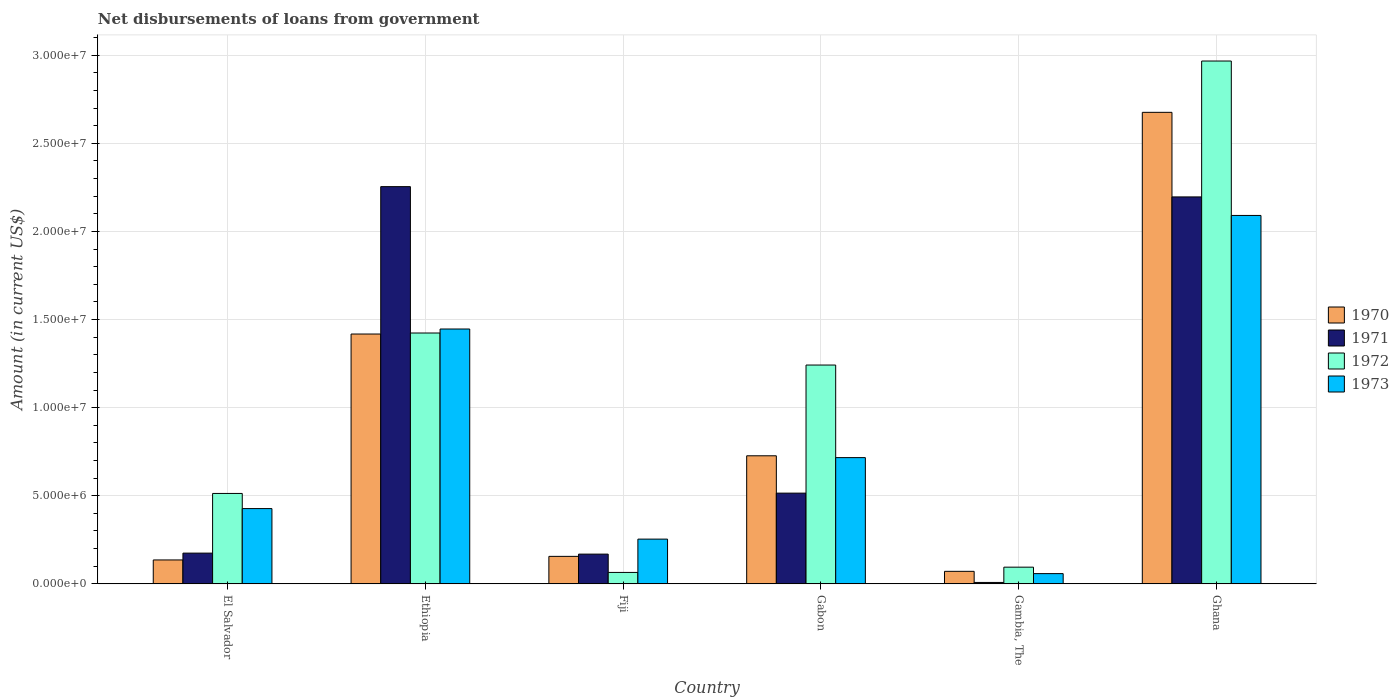How many different coloured bars are there?
Offer a terse response. 4. How many groups of bars are there?
Keep it short and to the point. 6. Are the number of bars per tick equal to the number of legend labels?
Ensure brevity in your answer.  Yes. Are the number of bars on each tick of the X-axis equal?
Make the answer very short. Yes. How many bars are there on the 2nd tick from the left?
Your response must be concise. 4. How many bars are there on the 6th tick from the right?
Offer a very short reply. 4. In how many cases, is the number of bars for a given country not equal to the number of legend labels?
Your response must be concise. 0. What is the amount of loan disbursed from government in 1972 in Gambia, The?
Make the answer very short. 9.48e+05. Across all countries, what is the maximum amount of loan disbursed from government in 1971?
Keep it short and to the point. 2.25e+07. Across all countries, what is the minimum amount of loan disbursed from government in 1973?
Ensure brevity in your answer.  5.81e+05. In which country was the amount of loan disbursed from government in 1973 maximum?
Keep it short and to the point. Ghana. In which country was the amount of loan disbursed from government in 1973 minimum?
Ensure brevity in your answer.  Gambia, The. What is the total amount of loan disbursed from government in 1972 in the graph?
Provide a succinct answer. 6.31e+07. What is the difference between the amount of loan disbursed from government in 1970 in Fiji and that in Gabon?
Offer a very short reply. -5.71e+06. What is the difference between the amount of loan disbursed from government in 1970 in Gambia, The and the amount of loan disbursed from government in 1973 in El Salvador?
Make the answer very short. -3.56e+06. What is the average amount of loan disbursed from government in 1973 per country?
Make the answer very short. 8.32e+06. What is the difference between the amount of loan disbursed from government of/in 1973 and amount of loan disbursed from government of/in 1970 in Ghana?
Your response must be concise. -5.85e+06. What is the ratio of the amount of loan disbursed from government in 1972 in Gambia, The to that in Ghana?
Make the answer very short. 0.03. What is the difference between the highest and the second highest amount of loan disbursed from government in 1970?
Give a very brief answer. 1.95e+07. What is the difference between the highest and the lowest amount of loan disbursed from government in 1970?
Ensure brevity in your answer.  2.60e+07. What does the 3rd bar from the left in Gabon represents?
Provide a succinct answer. 1972. What does the 3rd bar from the right in Fiji represents?
Provide a succinct answer. 1971. Is it the case that in every country, the sum of the amount of loan disbursed from government in 1972 and amount of loan disbursed from government in 1973 is greater than the amount of loan disbursed from government in 1971?
Keep it short and to the point. Yes. How many bars are there?
Offer a very short reply. 24. How many countries are there in the graph?
Your response must be concise. 6. What is the difference between two consecutive major ticks on the Y-axis?
Offer a very short reply. 5.00e+06. Are the values on the major ticks of Y-axis written in scientific E-notation?
Offer a terse response. Yes. Does the graph contain any zero values?
Your answer should be compact. No. Does the graph contain grids?
Your answer should be very brief. Yes. How are the legend labels stacked?
Keep it short and to the point. Vertical. What is the title of the graph?
Your answer should be very brief. Net disbursements of loans from government. Does "2003" appear as one of the legend labels in the graph?
Provide a succinct answer. No. What is the label or title of the Y-axis?
Offer a terse response. Amount (in current US$). What is the Amount (in current US$) in 1970 in El Salvador?
Provide a succinct answer. 1.36e+06. What is the Amount (in current US$) of 1971 in El Salvador?
Offer a terse response. 1.74e+06. What is the Amount (in current US$) of 1972 in El Salvador?
Offer a very short reply. 5.13e+06. What is the Amount (in current US$) in 1973 in El Salvador?
Your answer should be compact. 4.27e+06. What is the Amount (in current US$) in 1970 in Ethiopia?
Your answer should be compact. 1.42e+07. What is the Amount (in current US$) of 1971 in Ethiopia?
Provide a succinct answer. 2.25e+07. What is the Amount (in current US$) of 1972 in Ethiopia?
Make the answer very short. 1.42e+07. What is the Amount (in current US$) of 1973 in Ethiopia?
Give a very brief answer. 1.45e+07. What is the Amount (in current US$) of 1970 in Fiji?
Provide a succinct answer. 1.56e+06. What is the Amount (in current US$) in 1971 in Fiji?
Your answer should be compact. 1.69e+06. What is the Amount (in current US$) in 1972 in Fiji?
Offer a terse response. 6.49e+05. What is the Amount (in current US$) of 1973 in Fiji?
Make the answer very short. 2.54e+06. What is the Amount (in current US$) in 1970 in Gabon?
Provide a succinct answer. 7.27e+06. What is the Amount (in current US$) of 1971 in Gabon?
Provide a short and direct response. 5.15e+06. What is the Amount (in current US$) in 1972 in Gabon?
Offer a very short reply. 1.24e+07. What is the Amount (in current US$) of 1973 in Gabon?
Your answer should be very brief. 7.16e+06. What is the Amount (in current US$) in 1970 in Gambia, The?
Your answer should be compact. 7.11e+05. What is the Amount (in current US$) of 1972 in Gambia, The?
Keep it short and to the point. 9.48e+05. What is the Amount (in current US$) of 1973 in Gambia, The?
Your response must be concise. 5.81e+05. What is the Amount (in current US$) in 1970 in Ghana?
Ensure brevity in your answer.  2.68e+07. What is the Amount (in current US$) in 1971 in Ghana?
Your answer should be compact. 2.20e+07. What is the Amount (in current US$) of 1972 in Ghana?
Provide a short and direct response. 2.97e+07. What is the Amount (in current US$) in 1973 in Ghana?
Offer a terse response. 2.09e+07. Across all countries, what is the maximum Amount (in current US$) of 1970?
Offer a terse response. 2.68e+07. Across all countries, what is the maximum Amount (in current US$) of 1971?
Your answer should be very brief. 2.25e+07. Across all countries, what is the maximum Amount (in current US$) of 1972?
Make the answer very short. 2.97e+07. Across all countries, what is the maximum Amount (in current US$) of 1973?
Provide a succinct answer. 2.09e+07. Across all countries, what is the minimum Amount (in current US$) in 1970?
Keep it short and to the point. 7.11e+05. Across all countries, what is the minimum Amount (in current US$) of 1971?
Offer a terse response. 8.00e+04. Across all countries, what is the minimum Amount (in current US$) of 1972?
Your response must be concise. 6.49e+05. Across all countries, what is the minimum Amount (in current US$) of 1973?
Provide a succinct answer. 5.81e+05. What is the total Amount (in current US$) of 1970 in the graph?
Provide a short and direct response. 5.18e+07. What is the total Amount (in current US$) of 1971 in the graph?
Provide a succinct answer. 5.32e+07. What is the total Amount (in current US$) of 1972 in the graph?
Offer a very short reply. 6.31e+07. What is the total Amount (in current US$) of 1973 in the graph?
Provide a succinct answer. 4.99e+07. What is the difference between the Amount (in current US$) in 1970 in El Salvador and that in Ethiopia?
Your answer should be very brief. -1.28e+07. What is the difference between the Amount (in current US$) in 1971 in El Salvador and that in Ethiopia?
Offer a very short reply. -2.08e+07. What is the difference between the Amount (in current US$) of 1972 in El Salvador and that in Ethiopia?
Your answer should be very brief. -9.10e+06. What is the difference between the Amount (in current US$) of 1973 in El Salvador and that in Ethiopia?
Your response must be concise. -1.02e+07. What is the difference between the Amount (in current US$) of 1970 in El Salvador and that in Fiji?
Offer a very short reply. -2.03e+05. What is the difference between the Amount (in current US$) of 1971 in El Salvador and that in Fiji?
Ensure brevity in your answer.  5.70e+04. What is the difference between the Amount (in current US$) in 1972 in El Salvador and that in Fiji?
Keep it short and to the point. 4.48e+06. What is the difference between the Amount (in current US$) in 1973 in El Salvador and that in Fiji?
Keep it short and to the point. 1.73e+06. What is the difference between the Amount (in current US$) of 1970 in El Salvador and that in Gabon?
Offer a very short reply. -5.91e+06. What is the difference between the Amount (in current US$) of 1971 in El Salvador and that in Gabon?
Offer a terse response. -3.40e+06. What is the difference between the Amount (in current US$) in 1972 in El Salvador and that in Gabon?
Offer a terse response. -7.29e+06. What is the difference between the Amount (in current US$) in 1973 in El Salvador and that in Gabon?
Make the answer very short. -2.89e+06. What is the difference between the Amount (in current US$) in 1970 in El Salvador and that in Gambia, The?
Provide a succinct answer. 6.46e+05. What is the difference between the Amount (in current US$) in 1971 in El Salvador and that in Gambia, The?
Your answer should be compact. 1.66e+06. What is the difference between the Amount (in current US$) in 1972 in El Salvador and that in Gambia, The?
Ensure brevity in your answer.  4.18e+06. What is the difference between the Amount (in current US$) in 1973 in El Salvador and that in Gambia, The?
Your answer should be compact. 3.69e+06. What is the difference between the Amount (in current US$) in 1970 in El Salvador and that in Ghana?
Your answer should be very brief. -2.54e+07. What is the difference between the Amount (in current US$) in 1971 in El Salvador and that in Ghana?
Ensure brevity in your answer.  -2.02e+07. What is the difference between the Amount (in current US$) in 1972 in El Salvador and that in Ghana?
Give a very brief answer. -2.45e+07. What is the difference between the Amount (in current US$) of 1973 in El Salvador and that in Ghana?
Make the answer very short. -1.66e+07. What is the difference between the Amount (in current US$) in 1970 in Ethiopia and that in Fiji?
Provide a short and direct response. 1.26e+07. What is the difference between the Amount (in current US$) of 1971 in Ethiopia and that in Fiji?
Offer a very short reply. 2.09e+07. What is the difference between the Amount (in current US$) in 1972 in Ethiopia and that in Fiji?
Your response must be concise. 1.36e+07. What is the difference between the Amount (in current US$) of 1973 in Ethiopia and that in Fiji?
Ensure brevity in your answer.  1.19e+07. What is the difference between the Amount (in current US$) in 1970 in Ethiopia and that in Gabon?
Your answer should be very brief. 6.91e+06. What is the difference between the Amount (in current US$) in 1971 in Ethiopia and that in Gabon?
Keep it short and to the point. 1.74e+07. What is the difference between the Amount (in current US$) in 1972 in Ethiopia and that in Gabon?
Make the answer very short. 1.82e+06. What is the difference between the Amount (in current US$) of 1973 in Ethiopia and that in Gabon?
Make the answer very short. 7.30e+06. What is the difference between the Amount (in current US$) in 1970 in Ethiopia and that in Gambia, The?
Provide a short and direct response. 1.35e+07. What is the difference between the Amount (in current US$) in 1971 in Ethiopia and that in Gambia, The?
Provide a short and direct response. 2.25e+07. What is the difference between the Amount (in current US$) of 1972 in Ethiopia and that in Gambia, The?
Make the answer very short. 1.33e+07. What is the difference between the Amount (in current US$) in 1973 in Ethiopia and that in Gambia, The?
Give a very brief answer. 1.39e+07. What is the difference between the Amount (in current US$) in 1970 in Ethiopia and that in Ghana?
Offer a very short reply. -1.26e+07. What is the difference between the Amount (in current US$) in 1971 in Ethiopia and that in Ghana?
Ensure brevity in your answer.  5.83e+05. What is the difference between the Amount (in current US$) in 1972 in Ethiopia and that in Ghana?
Your answer should be very brief. -1.54e+07. What is the difference between the Amount (in current US$) in 1973 in Ethiopia and that in Ghana?
Offer a terse response. -6.44e+06. What is the difference between the Amount (in current US$) of 1970 in Fiji and that in Gabon?
Provide a short and direct response. -5.71e+06. What is the difference between the Amount (in current US$) in 1971 in Fiji and that in Gabon?
Your answer should be compact. -3.46e+06. What is the difference between the Amount (in current US$) of 1972 in Fiji and that in Gabon?
Ensure brevity in your answer.  -1.18e+07. What is the difference between the Amount (in current US$) in 1973 in Fiji and that in Gabon?
Make the answer very short. -4.62e+06. What is the difference between the Amount (in current US$) of 1970 in Fiji and that in Gambia, The?
Ensure brevity in your answer.  8.49e+05. What is the difference between the Amount (in current US$) of 1971 in Fiji and that in Gambia, The?
Offer a very short reply. 1.61e+06. What is the difference between the Amount (in current US$) in 1972 in Fiji and that in Gambia, The?
Provide a succinct answer. -2.99e+05. What is the difference between the Amount (in current US$) of 1973 in Fiji and that in Gambia, The?
Offer a very short reply. 1.96e+06. What is the difference between the Amount (in current US$) in 1970 in Fiji and that in Ghana?
Give a very brief answer. -2.52e+07. What is the difference between the Amount (in current US$) in 1971 in Fiji and that in Ghana?
Make the answer very short. -2.03e+07. What is the difference between the Amount (in current US$) of 1972 in Fiji and that in Ghana?
Offer a very short reply. -2.90e+07. What is the difference between the Amount (in current US$) in 1973 in Fiji and that in Ghana?
Your response must be concise. -1.84e+07. What is the difference between the Amount (in current US$) in 1970 in Gabon and that in Gambia, The?
Your response must be concise. 6.56e+06. What is the difference between the Amount (in current US$) of 1971 in Gabon and that in Gambia, The?
Provide a short and direct response. 5.07e+06. What is the difference between the Amount (in current US$) in 1972 in Gabon and that in Gambia, The?
Offer a very short reply. 1.15e+07. What is the difference between the Amount (in current US$) of 1973 in Gabon and that in Gambia, The?
Your response must be concise. 6.58e+06. What is the difference between the Amount (in current US$) in 1970 in Gabon and that in Ghana?
Offer a very short reply. -1.95e+07. What is the difference between the Amount (in current US$) of 1971 in Gabon and that in Ghana?
Give a very brief answer. -1.68e+07. What is the difference between the Amount (in current US$) in 1972 in Gabon and that in Ghana?
Keep it short and to the point. -1.73e+07. What is the difference between the Amount (in current US$) of 1973 in Gabon and that in Ghana?
Keep it short and to the point. -1.37e+07. What is the difference between the Amount (in current US$) of 1970 in Gambia, The and that in Ghana?
Keep it short and to the point. -2.60e+07. What is the difference between the Amount (in current US$) in 1971 in Gambia, The and that in Ghana?
Your answer should be compact. -2.19e+07. What is the difference between the Amount (in current US$) of 1972 in Gambia, The and that in Ghana?
Ensure brevity in your answer.  -2.87e+07. What is the difference between the Amount (in current US$) of 1973 in Gambia, The and that in Ghana?
Provide a short and direct response. -2.03e+07. What is the difference between the Amount (in current US$) in 1970 in El Salvador and the Amount (in current US$) in 1971 in Ethiopia?
Make the answer very short. -2.12e+07. What is the difference between the Amount (in current US$) in 1970 in El Salvador and the Amount (in current US$) in 1972 in Ethiopia?
Provide a short and direct response. -1.29e+07. What is the difference between the Amount (in current US$) in 1970 in El Salvador and the Amount (in current US$) in 1973 in Ethiopia?
Offer a very short reply. -1.31e+07. What is the difference between the Amount (in current US$) in 1971 in El Salvador and the Amount (in current US$) in 1972 in Ethiopia?
Offer a terse response. -1.25e+07. What is the difference between the Amount (in current US$) of 1971 in El Salvador and the Amount (in current US$) of 1973 in Ethiopia?
Provide a short and direct response. -1.27e+07. What is the difference between the Amount (in current US$) in 1972 in El Salvador and the Amount (in current US$) in 1973 in Ethiopia?
Give a very brief answer. -9.33e+06. What is the difference between the Amount (in current US$) of 1970 in El Salvador and the Amount (in current US$) of 1971 in Fiji?
Provide a succinct answer. -3.31e+05. What is the difference between the Amount (in current US$) in 1970 in El Salvador and the Amount (in current US$) in 1972 in Fiji?
Give a very brief answer. 7.08e+05. What is the difference between the Amount (in current US$) in 1970 in El Salvador and the Amount (in current US$) in 1973 in Fiji?
Provide a succinct answer. -1.18e+06. What is the difference between the Amount (in current US$) in 1971 in El Salvador and the Amount (in current US$) in 1972 in Fiji?
Give a very brief answer. 1.10e+06. What is the difference between the Amount (in current US$) in 1971 in El Salvador and the Amount (in current US$) in 1973 in Fiji?
Your answer should be compact. -7.94e+05. What is the difference between the Amount (in current US$) in 1972 in El Salvador and the Amount (in current US$) in 1973 in Fiji?
Give a very brief answer. 2.59e+06. What is the difference between the Amount (in current US$) of 1970 in El Salvador and the Amount (in current US$) of 1971 in Gabon?
Provide a short and direct response. -3.79e+06. What is the difference between the Amount (in current US$) of 1970 in El Salvador and the Amount (in current US$) of 1972 in Gabon?
Offer a very short reply. -1.11e+07. What is the difference between the Amount (in current US$) in 1970 in El Salvador and the Amount (in current US$) in 1973 in Gabon?
Make the answer very short. -5.81e+06. What is the difference between the Amount (in current US$) in 1971 in El Salvador and the Amount (in current US$) in 1972 in Gabon?
Your answer should be compact. -1.07e+07. What is the difference between the Amount (in current US$) of 1971 in El Salvador and the Amount (in current US$) of 1973 in Gabon?
Your answer should be compact. -5.42e+06. What is the difference between the Amount (in current US$) in 1972 in El Salvador and the Amount (in current US$) in 1973 in Gabon?
Make the answer very short. -2.03e+06. What is the difference between the Amount (in current US$) in 1970 in El Salvador and the Amount (in current US$) in 1971 in Gambia, The?
Offer a very short reply. 1.28e+06. What is the difference between the Amount (in current US$) of 1970 in El Salvador and the Amount (in current US$) of 1972 in Gambia, The?
Keep it short and to the point. 4.09e+05. What is the difference between the Amount (in current US$) of 1970 in El Salvador and the Amount (in current US$) of 1973 in Gambia, The?
Offer a very short reply. 7.76e+05. What is the difference between the Amount (in current US$) of 1971 in El Salvador and the Amount (in current US$) of 1972 in Gambia, The?
Your answer should be very brief. 7.97e+05. What is the difference between the Amount (in current US$) of 1971 in El Salvador and the Amount (in current US$) of 1973 in Gambia, The?
Offer a terse response. 1.16e+06. What is the difference between the Amount (in current US$) of 1972 in El Salvador and the Amount (in current US$) of 1973 in Gambia, The?
Your answer should be very brief. 4.55e+06. What is the difference between the Amount (in current US$) of 1970 in El Salvador and the Amount (in current US$) of 1971 in Ghana?
Ensure brevity in your answer.  -2.06e+07. What is the difference between the Amount (in current US$) of 1970 in El Salvador and the Amount (in current US$) of 1972 in Ghana?
Ensure brevity in your answer.  -2.83e+07. What is the difference between the Amount (in current US$) in 1970 in El Salvador and the Amount (in current US$) in 1973 in Ghana?
Offer a very short reply. -1.96e+07. What is the difference between the Amount (in current US$) in 1971 in El Salvador and the Amount (in current US$) in 1972 in Ghana?
Offer a terse response. -2.79e+07. What is the difference between the Amount (in current US$) of 1971 in El Salvador and the Amount (in current US$) of 1973 in Ghana?
Your answer should be very brief. -1.92e+07. What is the difference between the Amount (in current US$) of 1972 in El Salvador and the Amount (in current US$) of 1973 in Ghana?
Give a very brief answer. -1.58e+07. What is the difference between the Amount (in current US$) of 1970 in Ethiopia and the Amount (in current US$) of 1971 in Fiji?
Provide a short and direct response. 1.25e+07. What is the difference between the Amount (in current US$) of 1970 in Ethiopia and the Amount (in current US$) of 1972 in Fiji?
Offer a very short reply. 1.35e+07. What is the difference between the Amount (in current US$) in 1970 in Ethiopia and the Amount (in current US$) in 1973 in Fiji?
Give a very brief answer. 1.16e+07. What is the difference between the Amount (in current US$) in 1971 in Ethiopia and the Amount (in current US$) in 1972 in Fiji?
Your response must be concise. 2.19e+07. What is the difference between the Amount (in current US$) in 1971 in Ethiopia and the Amount (in current US$) in 1973 in Fiji?
Offer a very short reply. 2.00e+07. What is the difference between the Amount (in current US$) in 1972 in Ethiopia and the Amount (in current US$) in 1973 in Fiji?
Your response must be concise. 1.17e+07. What is the difference between the Amount (in current US$) in 1970 in Ethiopia and the Amount (in current US$) in 1971 in Gabon?
Offer a very short reply. 9.03e+06. What is the difference between the Amount (in current US$) in 1970 in Ethiopia and the Amount (in current US$) in 1972 in Gabon?
Your response must be concise. 1.76e+06. What is the difference between the Amount (in current US$) of 1970 in Ethiopia and the Amount (in current US$) of 1973 in Gabon?
Offer a very short reply. 7.01e+06. What is the difference between the Amount (in current US$) of 1971 in Ethiopia and the Amount (in current US$) of 1972 in Gabon?
Give a very brief answer. 1.01e+07. What is the difference between the Amount (in current US$) of 1971 in Ethiopia and the Amount (in current US$) of 1973 in Gabon?
Make the answer very short. 1.54e+07. What is the difference between the Amount (in current US$) in 1972 in Ethiopia and the Amount (in current US$) in 1973 in Gabon?
Offer a very short reply. 7.07e+06. What is the difference between the Amount (in current US$) in 1970 in Ethiopia and the Amount (in current US$) in 1971 in Gambia, The?
Your answer should be compact. 1.41e+07. What is the difference between the Amount (in current US$) in 1970 in Ethiopia and the Amount (in current US$) in 1972 in Gambia, The?
Offer a very short reply. 1.32e+07. What is the difference between the Amount (in current US$) of 1970 in Ethiopia and the Amount (in current US$) of 1973 in Gambia, The?
Your answer should be very brief. 1.36e+07. What is the difference between the Amount (in current US$) in 1971 in Ethiopia and the Amount (in current US$) in 1972 in Gambia, The?
Provide a succinct answer. 2.16e+07. What is the difference between the Amount (in current US$) in 1971 in Ethiopia and the Amount (in current US$) in 1973 in Gambia, The?
Your answer should be compact. 2.20e+07. What is the difference between the Amount (in current US$) of 1972 in Ethiopia and the Amount (in current US$) of 1973 in Gambia, The?
Your response must be concise. 1.37e+07. What is the difference between the Amount (in current US$) of 1970 in Ethiopia and the Amount (in current US$) of 1971 in Ghana?
Your answer should be very brief. -7.78e+06. What is the difference between the Amount (in current US$) of 1970 in Ethiopia and the Amount (in current US$) of 1972 in Ghana?
Your answer should be very brief. -1.55e+07. What is the difference between the Amount (in current US$) of 1970 in Ethiopia and the Amount (in current US$) of 1973 in Ghana?
Offer a terse response. -6.73e+06. What is the difference between the Amount (in current US$) of 1971 in Ethiopia and the Amount (in current US$) of 1972 in Ghana?
Your response must be concise. -7.13e+06. What is the difference between the Amount (in current US$) in 1971 in Ethiopia and the Amount (in current US$) in 1973 in Ghana?
Your answer should be very brief. 1.64e+06. What is the difference between the Amount (in current US$) in 1972 in Ethiopia and the Amount (in current US$) in 1973 in Ghana?
Your answer should be compact. -6.67e+06. What is the difference between the Amount (in current US$) in 1970 in Fiji and the Amount (in current US$) in 1971 in Gabon?
Ensure brevity in your answer.  -3.59e+06. What is the difference between the Amount (in current US$) of 1970 in Fiji and the Amount (in current US$) of 1972 in Gabon?
Offer a terse response. -1.09e+07. What is the difference between the Amount (in current US$) of 1970 in Fiji and the Amount (in current US$) of 1973 in Gabon?
Ensure brevity in your answer.  -5.60e+06. What is the difference between the Amount (in current US$) of 1971 in Fiji and the Amount (in current US$) of 1972 in Gabon?
Ensure brevity in your answer.  -1.07e+07. What is the difference between the Amount (in current US$) of 1971 in Fiji and the Amount (in current US$) of 1973 in Gabon?
Make the answer very short. -5.48e+06. What is the difference between the Amount (in current US$) of 1972 in Fiji and the Amount (in current US$) of 1973 in Gabon?
Provide a succinct answer. -6.52e+06. What is the difference between the Amount (in current US$) in 1970 in Fiji and the Amount (in current US$) in 1971 in Gambia, The?
Ensure brevity in your answer.  1.48e+06. What is the difference between the Amount (in current US$) of 1970 in Fiji and the Amount (in current US$) of 1972 in Gambia, The?
Provide a short and direct response. 6.12e+05. What is the difference between the Amount (in current US$) in 1970 in Fiji and the Amount (in current US$) in 1973 in Gambia, The?
Provide a short and direct response. 9.79e+05. What is the difference between the Amount (in current US$) of 1971 in Fiji and the Amount (in current US$) of 1972 in Gambia, The?
Keep it short and to the point. 7.40e+05. What is the difference between the Amount (in current US$) of 1971 in Fiji and the Amount (in current US$) of 1973 in Gambia, The?
Offer a very short reply. 1.11e+06. What is the difference between the Amount (in current US$) in 1972 in Fiji and the Amount (in current US$) in 1973 in Gambia, The?
Your answer should be compact. 6.80e+04. What is the difference between the Amount (in current US$) in 1970 in Fiji and the Amount (in current US$) in 1971 in Ghana?
Provide a succinct answer. -2.04e+07. What is the difference between the Amount (in current US$) of 1970 in Fiji and the Amount (in current US$) of 1972 in Ghana?
Provide a succinct answer. -2.81e+07. What is the difference between the Amount (in current US$) of 1970 in Fiji and the Amount (in current US$) of 1973 in Ghana?
Give a very brief answer. -1.93e+07. What is the difference between the Amount (in current US$) in 1971 in Fiji and the Amount (in current US$) in 1972 in Ghana?
Provide a succinct answer. -2.80e+07. What is the difference between the Amount (in current US$) of 1971 in Fiji and the Amount (in current US$) of 1973 in Ghana?
Provide a short and direct response. -1.92e+07. What is the difference between the Amount (in current US$) in 1972 in Fiji and the Amount (in current US$) in 1973 in Ghana?
Ensure brevity in your answer.  -2.03e+07. What is the difference between the Amount (in current US$) in 1970 in Gabon and the Amount (in current US$) in 1971 in Gambia, The?
Provide a short and direct response. 7.19e+06. What is the difference between the Amount (in current US$) in 1970 in Gabon and the Amount (in current US$) in 1972 in Gambia, The?
Keep it short and to the point. 6.32e+06. What is the difference between the Amount (in current US$) in 1970 in Gabon and the Amount (in current US$) in 1973 in Gambia, The?
Offer a terse response. 6.69e+06. What is the difference between the Amount (in current US$) in 1971 in Gabon and the Amount (in current US$) in 1972 in Gambia, The?
Your answer should be very brief. 4.20e+06. What is the difference between the Amount (in current US$) in 1971 in Gabon and the Amount (in current US$) in 1973 in Gambia, The?
Offer a very short reply. 4.57e+06. What is the difference between the Amount (in current US$) in 1972 in Gabon and the Amount (in current US$) in 1973 in Gambia, The?
Ensure brevity in your answer.  1.18e+07. What is the difference between the Amount (in current US$) of 1970 in Gabon and the Amount (in current US$) of 1971 in Ghana?
Provide a short and direct response. -1.47e+07. What is the difference between the Amount (in current US$) in 1970 in Gabon and the Amount (in current US$) in 1972 in Ghana?
Your answer should be very brief. -2.24e+07. What is the difference between the Amount (in current US$) in 1970 in Gabon and the Amount (in current US$) in 1973 in Ghana?
Provide a succinct answer. -1.36e+07. What is the difference between the Amount (in current US$) of 1971 in Gabon and the Amount (in current US$) of 1972 in Ghana?
Offer a very short reply. -2.45e+07. What is the difference between the Amount (in current US$) in 1971 in Gabon and the Amount (in current US$) in 1973 in Ghana?
Your answer should be compact. -1.58e+07. What is the difference between the Amount (in current US$) of 1972 in Gabon and the Amount (in current US$) of 1973 in Ghana?
Give a very brief answer. -8.49e+06. What is the difference between the Amount (in current US$) in 1970 in Gambia, The and the Amount (in current US$) in 1971 in Ghana?
Your answer should be very brief. -2.12e+07. What is the difference between the Amount (in current US$) of 1970 in Gambia, The and the Amount (in current US$) of 1972 in Ghana?
Provide a short and direct response. -2.90e+07. What is the difference between the Amount (in current US$) in 1970 in Gambia, The and the Amount (in current US$) in 1973 in Ghana?
Provide a short and direct response. -2.02e+07. What is the difference between the Amount (in current US$) in 1971 in Gambia, The and the Amount (in current US$) in 1972 in Ghana?
Your response must be concise. -2.96e+07. What is the difference between the Amount (in current US$) of 1971 in Gambia, The and the Amount (in current US$) of 1973 in Ghana?
Provide a short and direct response. -2.08e+07. What is the difference between the Amount (in current US$) in 1972 in Gambia, The and the Amount (in current US$) in 1973 in Ghana?
Ensure brevity in your answer.  -2.00e+07. What is the average Amount (in current US$) in 1970 per country?
Give a very brief answer. 8.64e+06. What is the average Amount (in current US$) in 1971 per country?
Give a very brief answer. 8.86e+06. What is the average Amount (in current US$) in 1972 per country?
Your answer should be very brief. 1.05e+07. What is the average Amount (in current US$) of 1973 per country?
Provide a short and direct response. 8.32e+06. What is the difference between the Amount (in current US$) of 1970 and Amount (in current US$) of 1971 in El Salvador?
Make the answer very short. -3.88e+05. What is the difference between the Amount (in current US$) of 1970 and Amount (in current US$) of 1972 in El Salvador?
Provide a succinct answer. -3.77e+06. What is the difference between the Amount (in current US$) of 1970 and Amount (in current US$) of 1973 in El Salvador?
Give a very brief answer. -2.92e+06. What is the difference between the Amount (in current US$) of 1971 and Amount (in current US$) of 1972 in El Salvador?
Your answer should be compact. -3.39e+06. What is the difference between the Amount (in current US$) in 1971 and Amount (in current US$) in 1973 in El Salvador?
Your answer should be very brief. -2.53e+06. What is the difference between the Amount (in current US$) in 1972 and Amount (in current US$) in 1973 in El Salvador?
Your answer should be compact. 8.59e+05. What is the difference between the Amount (in current US$) of 1970 and Amount (in current US$) of 1971 in Ethiopia?
Your answer should be compact. -8.36e+06. What is the difference between the Amount (in current US$) of 1970 and Amount (in current US$) of 1972 in Ethiopia?
Make the answer very short. -5.80e+04. What is the difference between the Amount (in current US$) in 1970 and Amount (in current US$) in 1973 in Ethiopia?
Provide a succinct answer. -2.85e+05. What is the difference between the Amount (in current US$) in 1971 and Amount (in current US$) in 1972 in Ethiopia?
Give a very brief answer. 8.31e+06. What is the difference between the Amount (in current US$) in 1971 and Amount (in current US$) in 1973 in Ethiopia?
Give a very brief answer. 8.08e+06. What is the difference between the Amount (in current US$) in 1972 and Amount (in current US$) in 1973 in Ethiopia?
Offer a terse response. -2.27e+05. What is the difference between the Amount (in current US$) of 1970 and Amount (in current US$) of 1971 in Fiji?
Provide a short and direct response. -1.28e+05. What is the difference between the Amount (in current US$) in 1970 and Amount (in current US$) in 1972 in Fiji?
Make the answer very short. 9.11e+05. What is the difference between the Amount (in current US$) in 1970 and Amount (in current US$) in 1973 in Fiji?
Offer a terse response. -9.79e+05. What is the difference between the Amount (in current US$) in 1971 and Amount (in current US$) in 1972 in Fiji?
Your response must be concise. 1.04e+06. What is the difference between the Amount (in current US$) of 1971 and Amount (in current US$) of 1973 in Fiji?
Keep it short and to the point. -8.51e+05. What is the difference between the Amount (in current US$) in 1972 and Amount (in current US$) in 1973 in Fiji?
Offer a terse response. -1.89e+06. What is the difference between the Amount (in current US$) in 1970 and Amount (in current US$) in 1971 in Gabon?
Make the answer very short. 2.12e+06. What is the difference between the Amount (in current US$) of 1970 and Amount (in current US$) of 1972 in Gabon?
Provide a succinct answer. -5.15e+06. What is the difference between the Amount (in current US$) of 1970 and Amount (in current US$) of 1973 in Gabon?
Ensure brevity in your answer.  1.04e+05. What is the difference between the Amount (in current US$) of 1971 and Amount (in current US$) of 1972 in Gabon?
Keep it short and to the point. -7.27e+06. What is the difference between the Amount (in current US$) of 1971 and Amount (in current US$) of 1973 in Gabon?
Offer a very short reply. -2.02e+06. What is the difference between the Amount (in current US$) of 1972 and Amount (in current US$) of 1973 in Gabon?
Provide a succinct answer. 5.25e+06. What is the difference between the Amount (in current US$) in 1970 and Amount (in current US$) in 1971 in Gambia, The?
Provide a succinct answer. 6.31e+05. What is the difference between the Amount (in current US$) of 1970 and Amount (in current US$) of 1972 in Gambia, The?
Your answer should be very brief. -2.37e+05. What is the difference between the Amount (in current US$) of 1970 and Amount (in current US$) of 1973 in Gambia, The?
Offer a terse response. 1.30e+05. What is the difference between the Amount (in current US$) of 1971 and Amount (in current US$) of 1972 in Gambia, The?
Make the answer very short. -8.68e+05. What is the difference between the Amount (in current US$) in 1971 and Amount (in current US$) in 1973 in Gambia, The?
Keep it short and to the point. -5.01e+05. What is the difference between the Amount (in current US$) of 1972 and Amount (in current US$) of 1973 in Gambia, The?
Provide a short and direct response. 3.67e+05. What is the difference between the Amount (in current US$) of 1970 and Amount (in current US$) of 1971 in Ghana?
Your response must be concise. 4.80e+06. What is the difference between the Amount (in current US$) in 1970 and Amount (in current US$) in 1972 in Ghana?
Make the answer very short. -2.91e+06. What is the difference between the Amount (in current US$) of 1970 and Amount (in current US$) of 1973 in Ghana?
Offer a terse response. 5.85e+06. What is the difference between the Amount (in current US$) of 1971 and Amount (in current US$) of 1972 in Ghana?
Provide a short and direct response. -7.71e+06. What is the difference between the Amount (in current US$) of 1971 and Amount (in current US$) of 1973 in Ghana?
Offer a very short reply. 1.05e+06. What is the difference between the Amount (in current US$) of 1972 and Amount (in current US$) of 1973 in Ghana?
Make the answer very short. 8.76e+06. What is the ratio of the Amount (in current US$) of 1970 in El Salvador to that in Ethiopia?
Provide a short and direct response. 0.1. What is the ratio of the Amount (in current US$) of 1971 in El Salvador to that in Ethiopia?
Ensure brevity in your answer.  0.08. What is the ratio of the Amount (in current US$) of 1972 in El Salvador to that in Ethiopia?
Your answer should be very brief. 0.36. What is the ratio of the Amount (in current US$) in 1973 in El Salvador to that in Ethiopia?
Offer a terse response. 0.3. What is the ratio of the Amount (in current US$) in 1970 in El Salvador to that in Fiji?
Give a very brief answer. 0.87. What is the ratio of the Amount (in current US$) of 1971 in El Salvador to that in Fiji?
Make the answer very short. 1.03. What is the ratio of the Amount (in current US$) in 1972 in El Salvador to that in Fiji?
Keep it short and to the point. 7.91. What is the ratio of the Amount (in current US$) of 1973 in El Salvador to that in Fiji?
Offer a very short reply. 1.68. What is the ratio of the Amount (in current US$) in 1970 in El Salvador to that in Gabon?
Your answer should be very brief. 0.19. What is the ratio of the Amount (in current US$) of 1971 in El Salvador to that in Gabon?
Your answer should be compact. 0.34. What is the ratio of the Amount (in current US$) in 1972 in El Salvador to that in Gabon?
Your response must be concise. 0.41. What is the ratio of the Amount (in current US$) of 1973 in El Salvador to that in Gabon?
Keep it short and to the point. 0.6. What is the ratio of the Amount (in current US$) of 1970 in El Salvador to that in Gambia, The?
Your answer should be compact. 1.91. What is the ratio of the Amount (in current US$) in 1971 in El Salvador to that in Gambia, The?
Ensure brevity in your answer.  21.81. What is the ratio of the Amount (in current US$) of 1972 in El Salvador to that in Gambia, The?
Your answer should be compact. 5.41. What is the ratio of the Amount (in current US$) of 1973 in El Salvador to that in Gambia, The?
Your answer should be compact. 7.35. What is the ratio of the Amount (in current US$) in 1970 in El Salvador to that in Ghana?
Your answer should be compact. 0.05. What is the ratio of the Amount (in current US$) in 1971 in El Salvador to that in Ghana?
Offer a terse response. 0.08. What is the ratio of the Amount (in current US$) in 1972 in El Salvador to that in Ghana?
Provide a succinct answer. 0.17. What is the ratio of the Amount (in current US$) in 1973 in El Salvador to that in Ghana?
Provide a succinct answer. 0.2. What is the ratio of the Amount (in current US$) in 1970 in Ethiopia to that in Fiji?
Your answer should be very brief. 9.09. What is the ratio of the Amount (in current US$) of 1971 in Ethiopia to that in Fiji?
Keep it short and to the point. 13.35. What is the ratio of the Amount (in current US$) in 1972 in Ethiopia to that in Fiji?
Your response must be concise. 21.94. What is the ratio of the Amount (in current US$) of 1973 in Ethiopia to that in Fiji?
Your answer should be very brief. 5.7. What is the ratio of the Amount (in current US$) in 1970 in Ethiopia to that in Gabon?
Your response must be concise. 1.95. What is the ratio of the Amount (in current US$) in 1971 in Ethiopia to that in Gabon?
Your response must be concise. 4.38. What is the ratio of the Amount (in current US$) in 1972 in Ethiopia to that in Gabon?
Make the answer very short. 1.15. What is the ratio of the Amount (in current US$) in 1973 in Ethiopia to that in Gabon?
Ensure brevity in your answer.  2.02. What is the ratio of the Amount (in current US$) in 1970 in Ethiopia to that in Gambia, The?
Ensure brevity in your answer.  19.94. What is the ratio of the Amount (in current US$) in 1971 in Ethiopia to that in Gambia, The?
Your response must be concise. 281.77. What is the ratio of the Amount (in current US$) in 1972 in Ethiopia to that in Gambia, The?
Offer a terse response. 15.02. What is the ratio of the Amount (in current US$) of 1973 in Ethiopia to that in Gambia, The?
Offer a terse response. 24.89. What is the ratio of the Amount (in current US$) of 1970 in Ethiopia to that in Ghana?
Offer a terse response. 0.53. What is the ratio of the Amount (in current US$) of 1971 in Ethiopia to that in Ghana?
Make the answer very short. 1.03. What is the ratio of the Amount (in current US$) of 1972 in Ethiopia to that in Ghana?
Your answer should be compact. 0.48. What is the ratio of the Amount (in current US$) of 1973 in Ethiopia to that in Ghana?
Give a very brief answer. 0.69. What is the ratio of the Amount (in current US$) of 1970 in Fiji to that in Gabon?
Offer a terse response. 0.21. What is the ratio of the Amount (in current US$) of 1971 in Fiji to that in Gabon?
Provide a short and direct response. 0.33. What is the ratio of the Amount (in current US$) in 1972 in Fiji to that in Gabon?
Your answer should be compact. 0.05. What is the ratio of the Amount (in current US$) in 1973 in Fiji to that in Gabon?
Ensure brevity in your answer.  0.35. What is the ratio of the Amount (in current US$) in 1970 in Fiji to that in Gambia, The?
Provide a short and direct response. 2.19. What is the ratio of the Amount (in current US$) in 1971 in Fiji to that in Gambia, The?
Provide a succinct answer. 21.1. What is the ratio of the Amount (in current US$) in 1972 in Fiji to that in Gambia, The?
Offer a terse response. 0.68. What is the ratio of the Amount (in current US$) in 1973 in Fiji to that in Gambia, The?
Your response must be concise. 4.37. What is the ratio of the Amount (in current US$) in 1970 in Fiji to that in Ghana?
Your response must be concise. 0.06. What is the ratio of the Amount (in current US$) of 1971 in Fiji to that in Ghana?
Your response must be concise. 0.08. What is the ratio of the Amount (in current US$) of 1972 in Fiji to that in Ghana?
Your answer should be very brief. 0.02. What is the ratio of the Amount (in current US$) of 1973 in Fiji to that in Ghana?
Your answer should be compact. 0.12. What is the ratio of the Amount (in current US$) of 1970 in Gabon to that in Gambia, The?
Your answer should be very brief. 10.22. What is the ratio of the Amount (in current US$) of 1971 in Gabon to that in Gambia, The?
Offer a very short reply. 64.36. What is the ratio of the Amount (in current US$) in 1972 in Gabon to that in Gambia, The?
Provide a short and direct response. 13.1. What is the ratio of the Amount (in current US$) of 1973 in Gabon to that in Gambia, The?
Your answer should be very brief. 12.33. What is the ratio of the Amount (in current US$) in 1970 in Gabon to that in Ghana?
Offer a terse response. 0.27. What is the ratio of the Amount (in current US$) in 1971 in Gabon to that in Ghana?
Your response must be concise. 0.23. What is the ratio of the Amount (in current US$) of 1972 in Gabon to that in Ghana?
Ensure brevity in your answer.  0.42. What is the ratio of the Amount (in current US$) in 1973 in Gabon to that in Ghana?
Give a very brief answer. 0.34. What is the ratio of the Amount (in current US$) of 1970 in Gambia, The to that in Ghana?
Offer a very short reply. 0.03. What is the ratio of the Amount (in current US$) of 1971 in Gambia, The to that in Ghana?
Keep it short and to the point. 0. What is the ratio of the Amount (in current US$) in 1972 in Gambia, The to that in Ghana?
Your answer should be very brief. 0.03. What is the ratio of the Amount (in current US$) in 1973 in Gambia, The to that in Ghana?
Provide a short and direct response. 0.03. What is the difference between the highest and the second highest Amount (in current US$) of 1970?
Provide a succinct answer. 1.26e+07. What is the difference between the highest and the second highest Amount (in current US$) of 1971?
Ensure brevity in your answer.  5.83e+05. What is the difference between the highest and the second highest Amount (in current US$) of 1972?
Provide a succinct answer. 1.54e+07. What is the difference between the highest and the second highest Amount (in current US$) in 1973?
Your response must be concise. 6.44e+06. What is the difference between the highest and the lowest Amount (in current US$) in 1970?
Provide a succinct answer. 2.60e+07. What is the difference between the highest and the lowest Amount (in current US$) in 1971?
Provide a short and direct response. 2.25e+07. What is the difference between the highest and the lowest Amount (in current US$) in 1972?
Offer a very short reply. 2.90e+07. What is the difference between the highest and the lowest Amount (in current US$) of 1973?
Your answer should be very brief. 2.03e+07. 